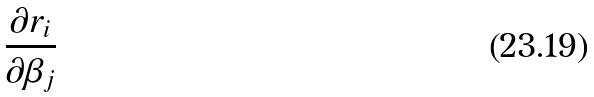Convert formula to latex. <formula><loc_0><loc_0><loc_500><loc_500>\frac { \partial r _ { i } } { \partial \beta _ { j } }</formula> 